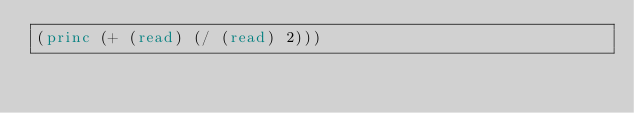<code> <loc_0><loc_0><loc_500><loc_500><_Lisp_>(princ (+ (read) (/ (read) 2)))</code> 